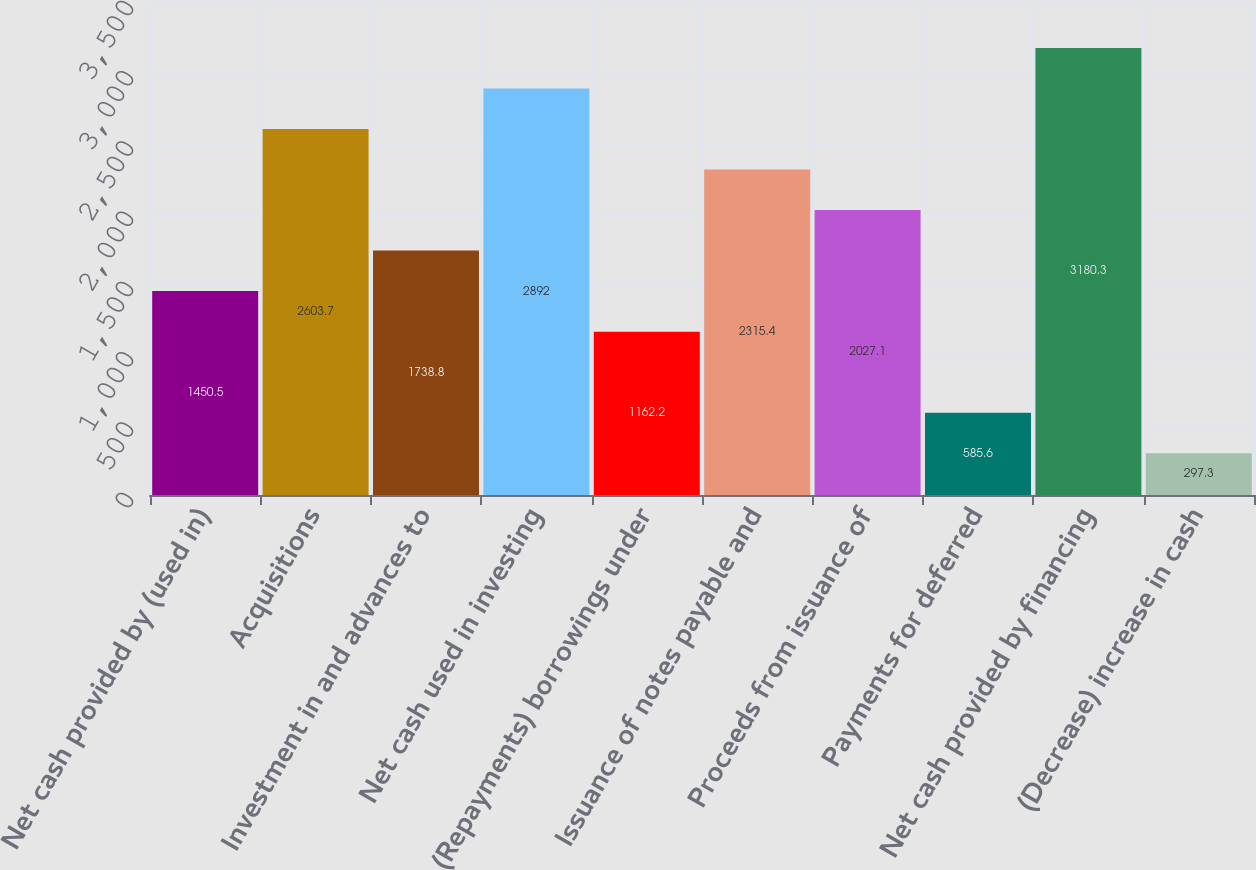<chart> <loc_0><loc_0><loc_500><loc_500><bar_chart><fcel>Net cash provided by (used in)<fcel>Acquisitions<fcel>Investment in and advances to<fcel>Net cash used in investing<fcel>(Repayments) borrowings under<fcel>Issuance of notes payable and<fcel>Proceeds from issuance of<fcel>Payments for deferred<fcel>Net cash provided by financing<fcel>(Decrease) increase in cash<nl><fcel>1450.5<fcel>2603.7<fcel>1738.8<fcel>2892<fcel>1162.2<fcel>2315.4<fcel>2027.1<fcel>585.6<fcel>3180.3<fcel>297.3<nl></chart> 